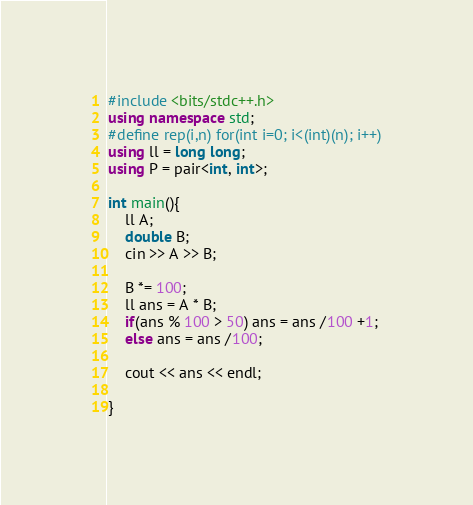<code> <loc_0><loc_0><loc_500><loc_500><_C++_>#include <bits/stdc++.h>
using namespace std;
#define rep(i,n) for(int i=0; i<(int)(n); i++)
using ll = long long;
using P = pair<int, int>;

int main(){
    ll A;
    double B;
    cin >> A >> B;

    B *= 100;
    ll ans = A * B;
    if(ans % 100 > 50) ans = ans /100 +1;
    else ans = ans /100;

    cout << ans << endl;
    
}</code> 